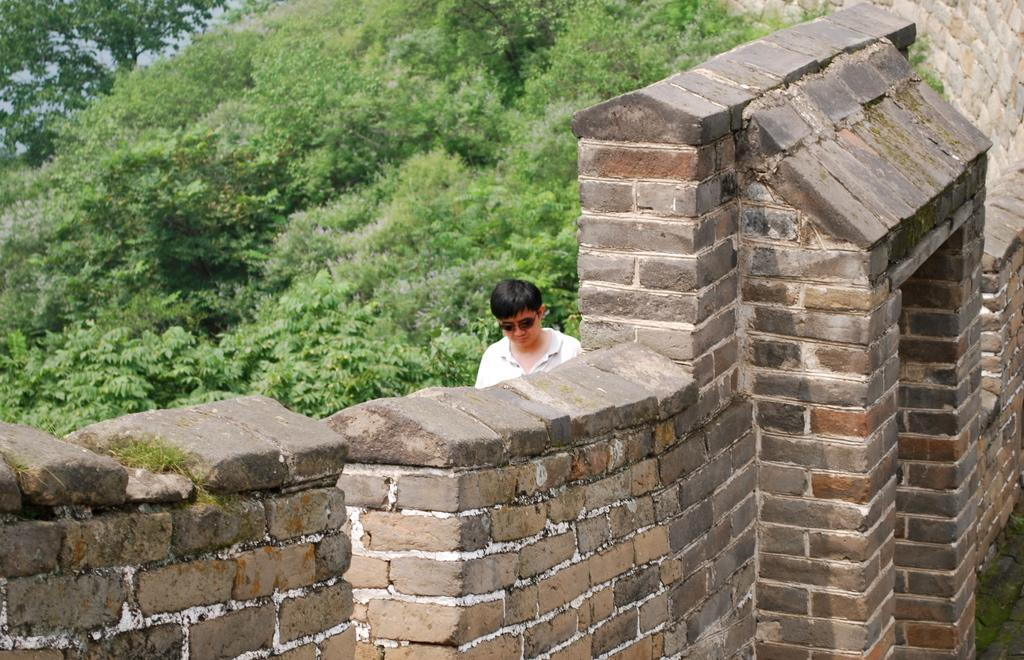What is present in the image besides the man? There is a wall in the image. Where is the man located in relation to the wall? The man is beside the wall. What can be seen in the background of the image? There are trees in the background of the image. What type of oatmeal is the man eating in the image? There is no oatmeal present in the image. Is the man in jail in the image? There is no indication in the image that the man is in jail. What color is the scarf the man is wearing in the image? The man is not wearing a scarf in the image. 